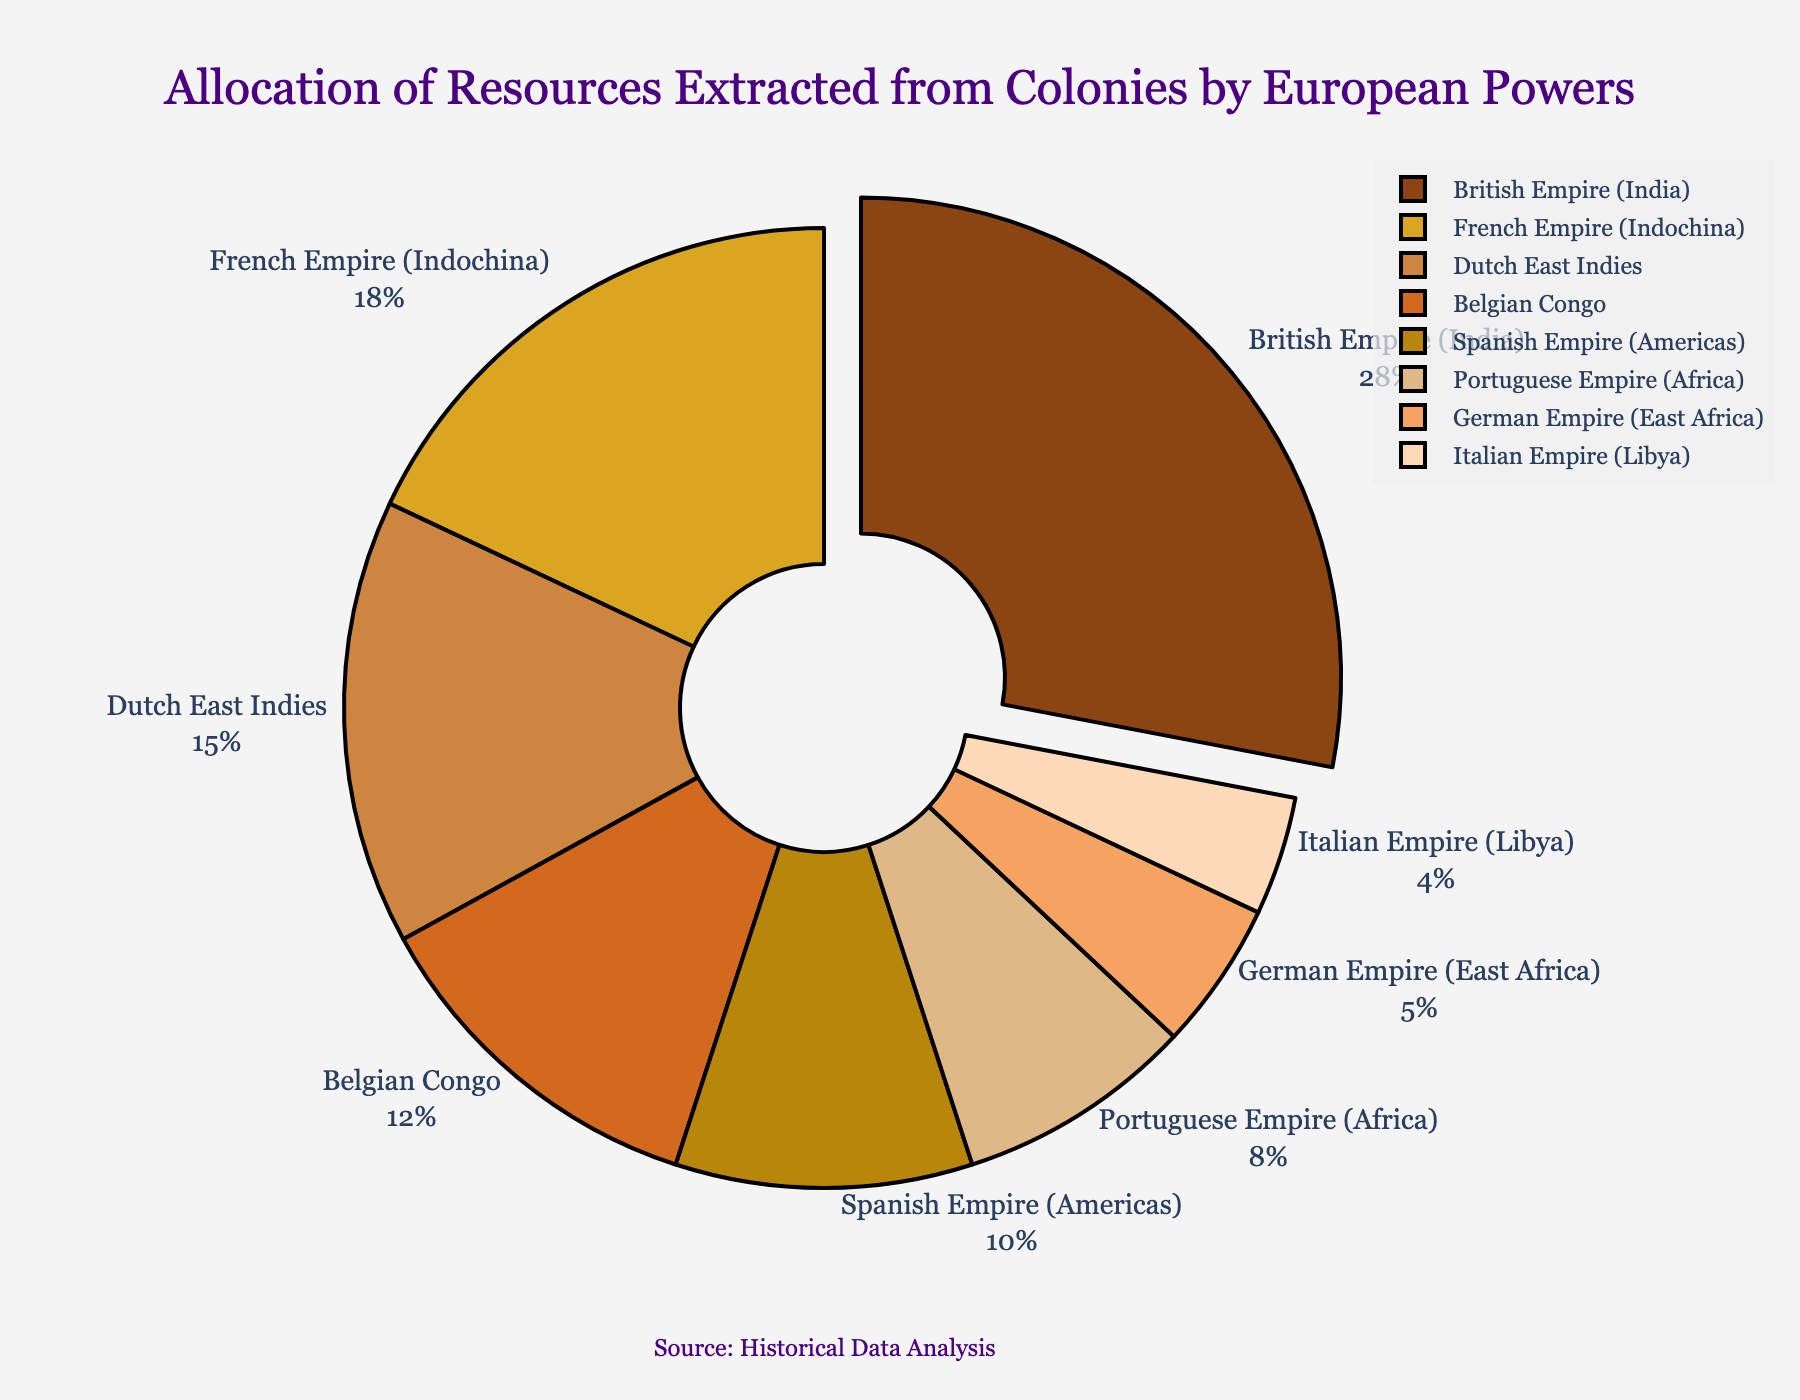Which European power extracted the largest percentage of resources from its colonies? The largest segment of the pie chart corresponds to the British Empire (India), which accounts for 28% of the resources extracted.
Answer: British Empire (India) What is the combined percentage of resources extracted by the French Empire (Indochina) and the Dutch East Indies? In the pie chart, the French Empire (Indochina) and the Dutch East Indies have percentages of 18% and 15%, respectively. Adding these together gives 18% + 15% = 33%.
Answer: 33% Which colonies extracted less than 10% of the resources? In the pie chart, the segments representing less than 10% are the Portuguese Empire (Africa), German Empire (East Africa), and Italian Empire (Libya), with percentages of 8%, 5%, and 4% respectively.
Answer: Portuguese Empire (Africa), German Empire (East Africa), Italian Empire (Libya) Which two European powers together extracted more resources than the Belgian Congo but less than the British Empire (India)? The Belgian Congo extracted 12% of the resources. The combined extraction percentages of the Dutch East Indies (15%) and the Spanish Empire (Americas) (10%) are 15% + 10% = 25%, which is more than 12% but less than the British Empire's 28%.
Answer: Dutch East Indies and Spanish Empire (Americas) What percentage of resources was extracted from colonies in Africa (sum of Belgian Congo, Portuguese Empire, German Empire, and Italian Empire)? The percentages for colonies located in Africa are Belgian Congo (12%), Portuguese Empire (Africa) (8%), German Empire (East Africa) (5%), and Italian Empire (Libya) (4%). Summing these together gives 12% + 8% + 5% + 4% = 29%.
Answer: 29% Which color in the pie chart represents the Dutch East Indies? In the pie chart, the Dutch East Indies is represented by the third segment, which has a brownish color.
Answer: Brownish color By how much does the extraction percentage of the British Empire (India) exceed that of the Spanish Empire (Americas)? The extraction percentage of the British Empire (India) is 28%, and that of the Spanish Empire (Americas) is 10%. The difference is 28% - 10% = 18%.
Answer: 18% Which group extracted 5% of the resources, and what visual cue helps you identify it? The German Empire (East Africa) extracted 5% of the resources. This segment is illustrated by its textual label near the pie slice, and it's one of the smaller segments in the chart.
Answer: German Empire (East Africa) What is the difference between the resources extracted by the French Empire (Indochina) and the Italian Empire (Libya)? The French Empire (Indochina) extracted 18% of the resources, while the Italian Empire (Libya) extracted 4%. The difference is 18% - 4% = 14%.
Answer: 14% Is the segment representing the resources extracted by the British Empire (India) pulled out from the pie chart? Yes, the segment for the British Empire (India) is visually pulled out from the pie chart, making it stand out from the other segments.
Answer: Yes 